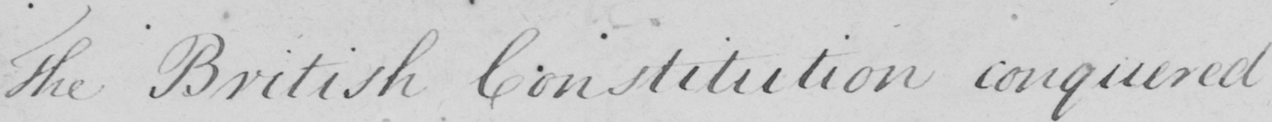What does this handwritten line say? The British Constitution conquered 